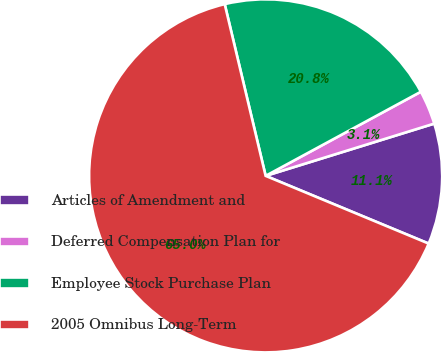<chart> <loc_0><loc_0><loc_500><loc_500><pie_chart><fcel>Articles of Amendment and<fcel>Deferred Compensation Plan for<fcel>Employee Stock Purchase Plan<fcel>2005 Omnibus Long-Term<nl><fcel>11.05%<fcel>3.12%<fcel>20.82%<fcel>65.01%<nl></chart> 